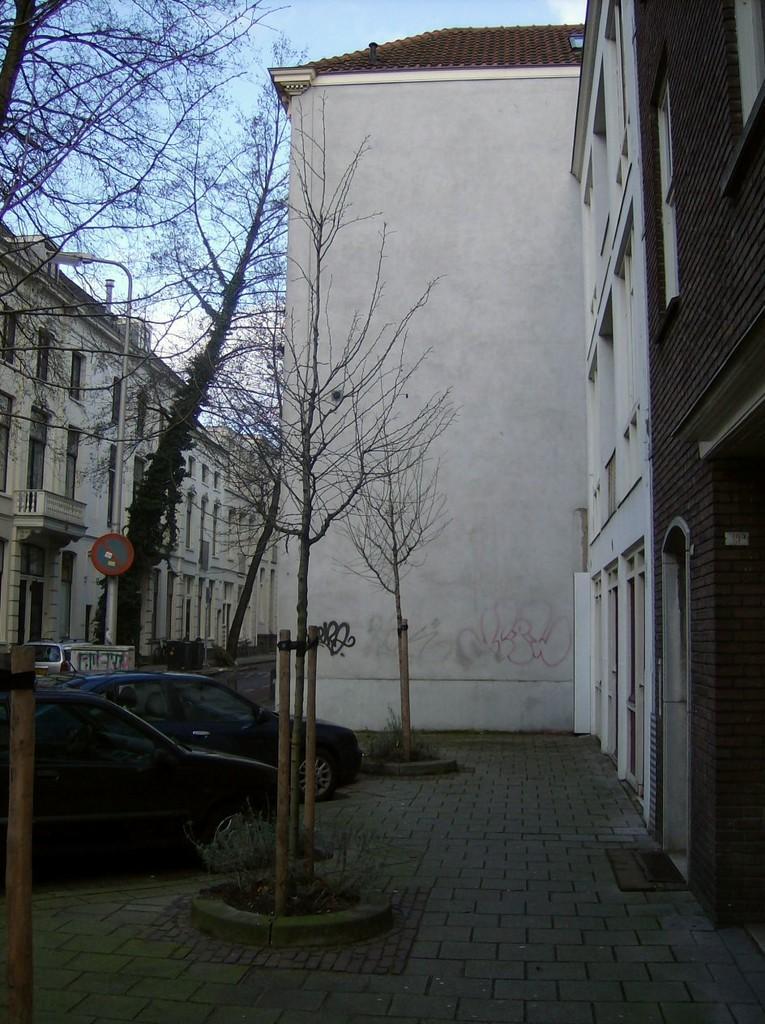Can you describe this image briefly? In this image we can see some buildings and there is a pavement. We can see some trees and vehicles and there is a pole with a sign board and street light. 